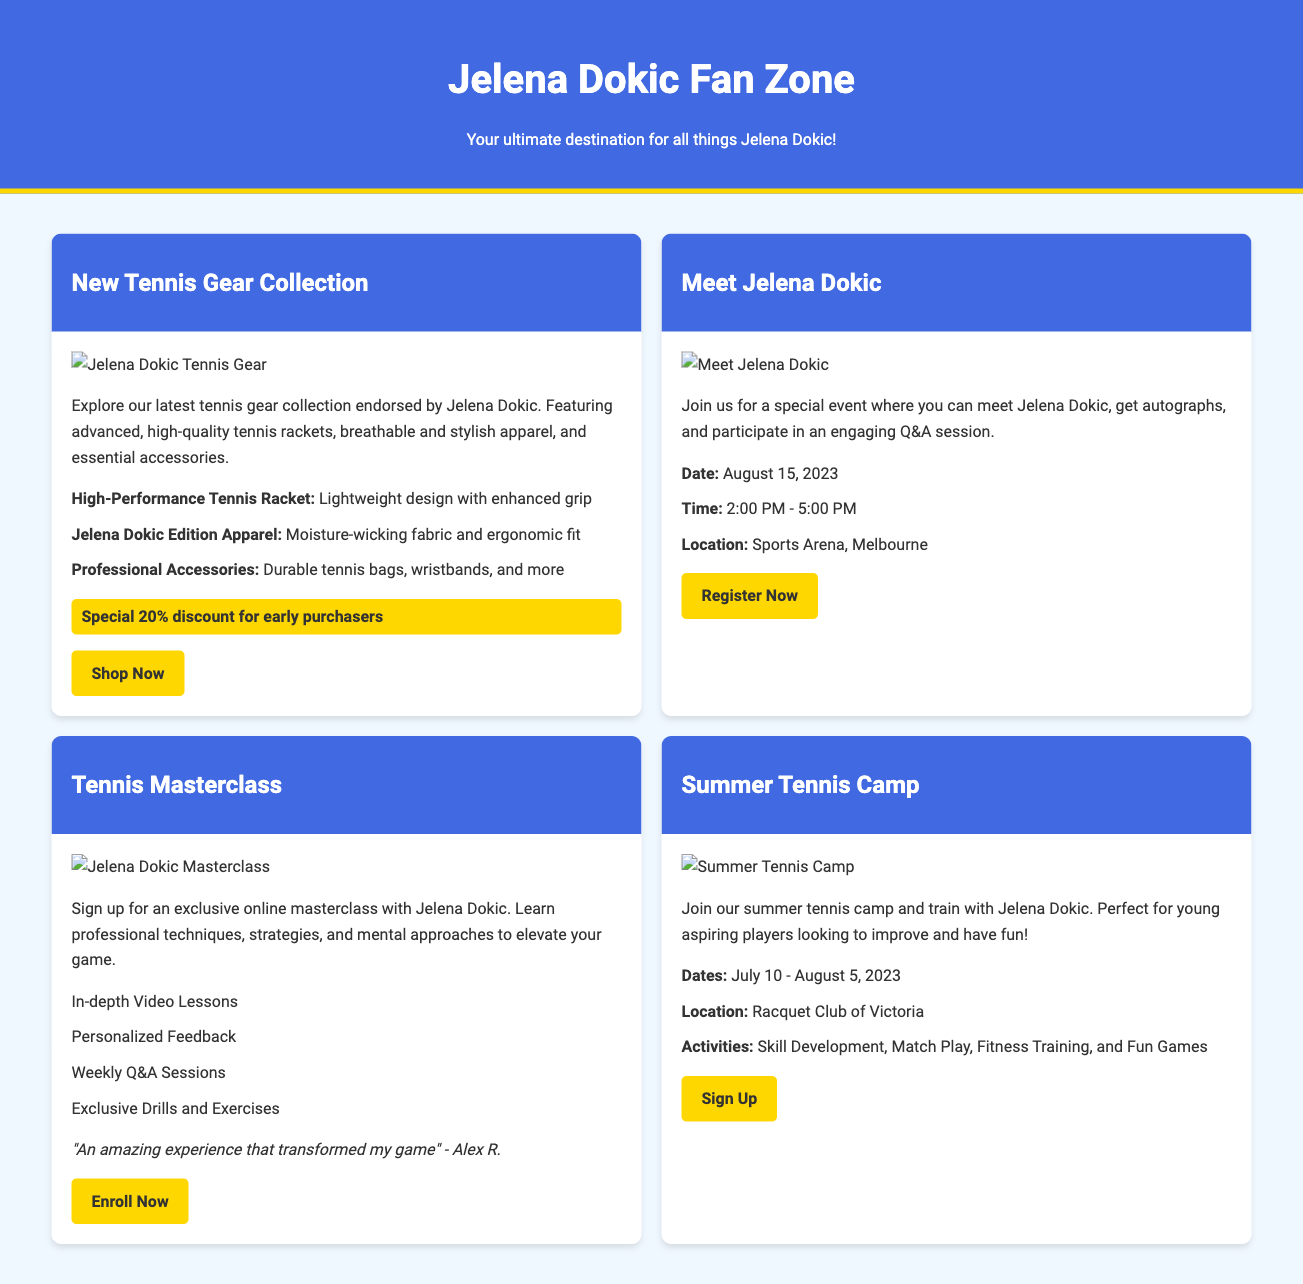what is the date of the Meet-and-Greet event? The document states that the date of the event is August 15, 2023.
Answer: August 15, 2023 what is the title of the online masterclass? The online masterclass is titled "Tennis Masterclass."
Answer: Tennis Masterclass how long is the Summer Tennis Camp running? The Summer Tennis Camp runs from July 10 to August 5, 2023.
Answer: July 10 - August 5, 2023 what special offer is mentioned for the new tennis gear? The document indicates a special discount of 20% for early purchasers.
Answer: 20% discount who is the featured athlete for the gear collection? The advertisement features Jelena Dokic for the gear collection.
Answer: Jelena Dokic what kind of feedback do previous masterclass participants provide? The document includes a testimonial stating, "An amazing experience that transformed my game."
Answer: transformed my game what is included in the summer camp activities? The activities listed include Skill Development, Match Play, Fitness Training, and Fun Games.
Answer: Skill Development, Match Play, Fitness Training, and Fun Games where is the Meet-and-Greet event taking place? The location for the event is at Sports Arena, Melbourne.
Answer: Sports Arena, Melbourne 